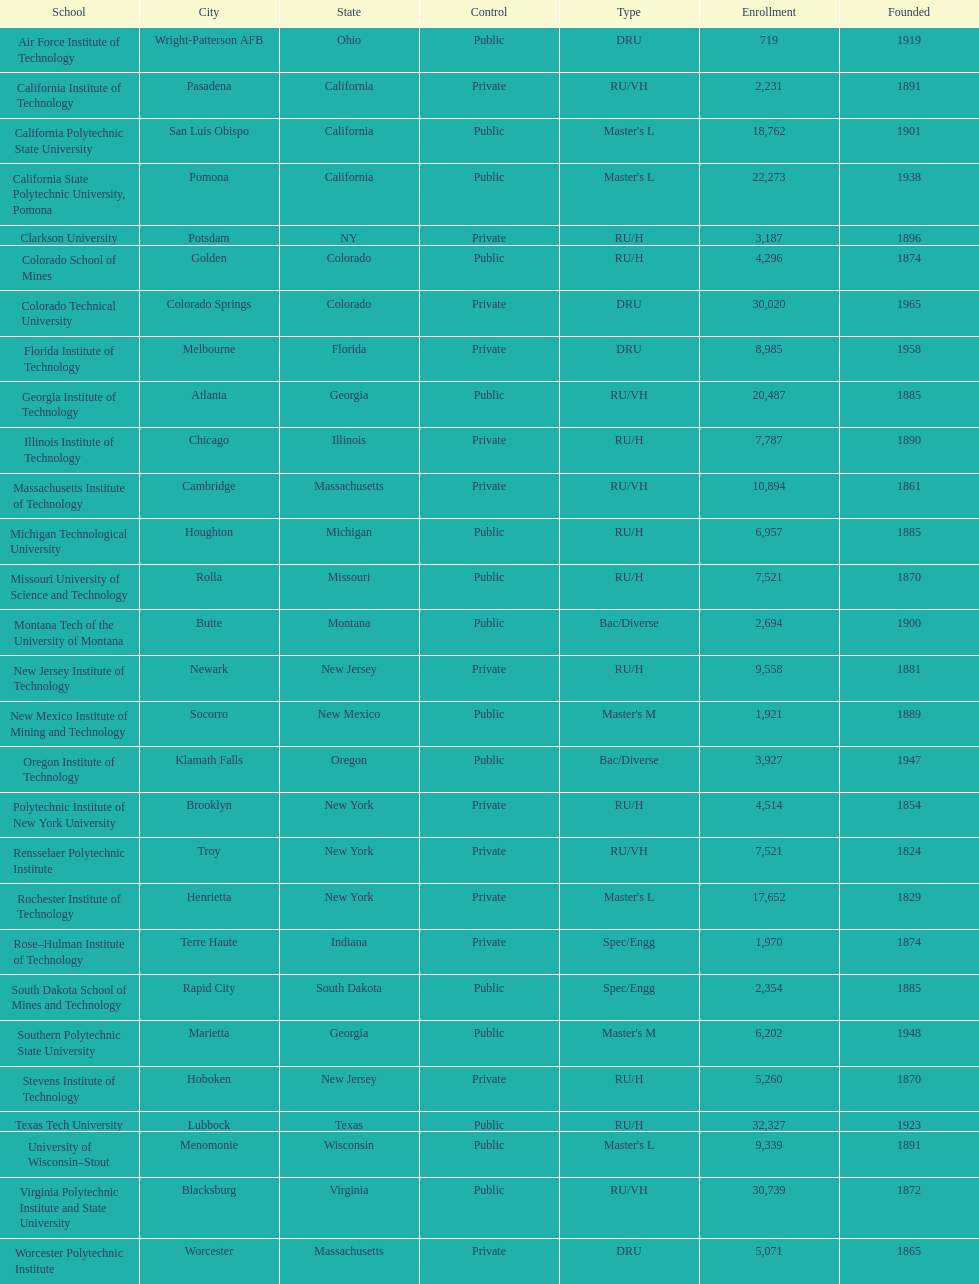What is the difference in enrollment between the top 2 schools listed in the table? 1512. 